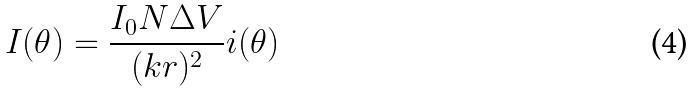<formula> <loc_0><loc_0><loc_500><loc_500>I ( \theta ) = \frac { I _ { 0 } N \Delta V } { ( k r ) ^ { 2 } } i ( \theta )</formula> 